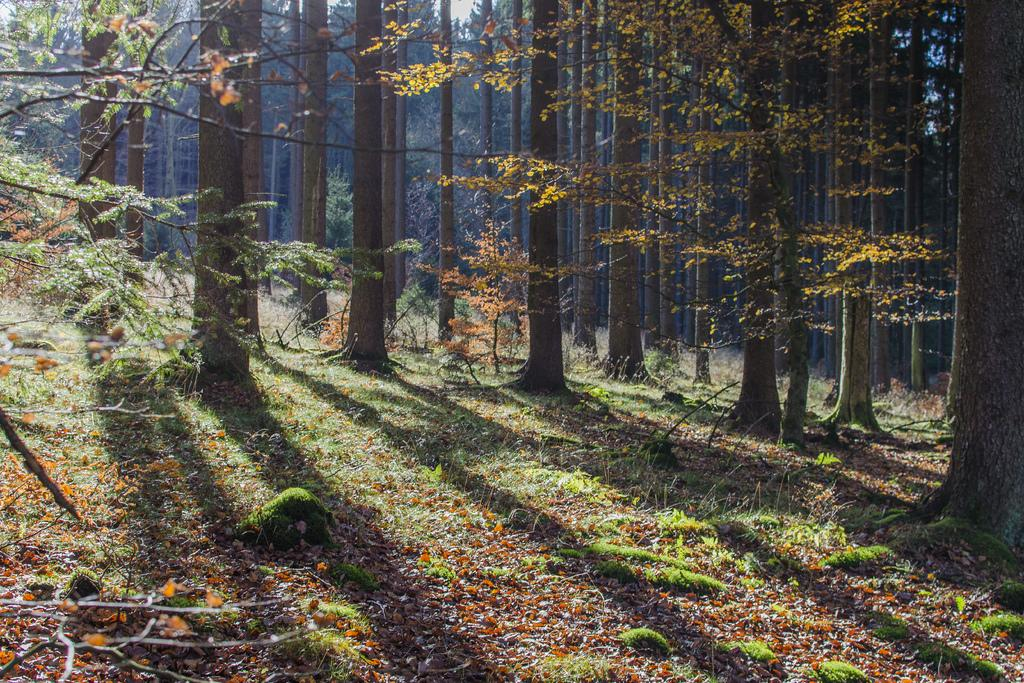What type of vegetation can be seen in the image? There are trees in the image. What is present at the bottom of the image? There are leaves and grass at the bottom of the image. How many lizards can be seen climbing the trees in the image? There are no lizards present in the image; it only features trees, leaves, and grass. 